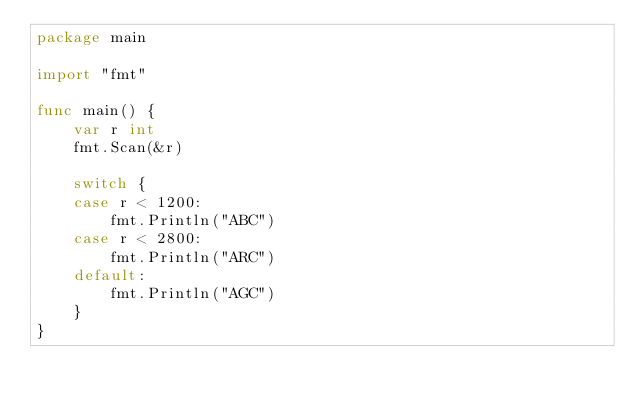Convert code to text. <code><loc_0><loc_0><loc_500><loc_500><_Go_>package main

import "fmt"

func main() {
	var r int
	fmt.Scan(&r)

	switch {
	case r < 1200:
		fmt.Println("ABC")
	case r < 2800:
		fmt.Println("ARC")
	default:
		fmt.Println("AGC")
	}
}
</code> 